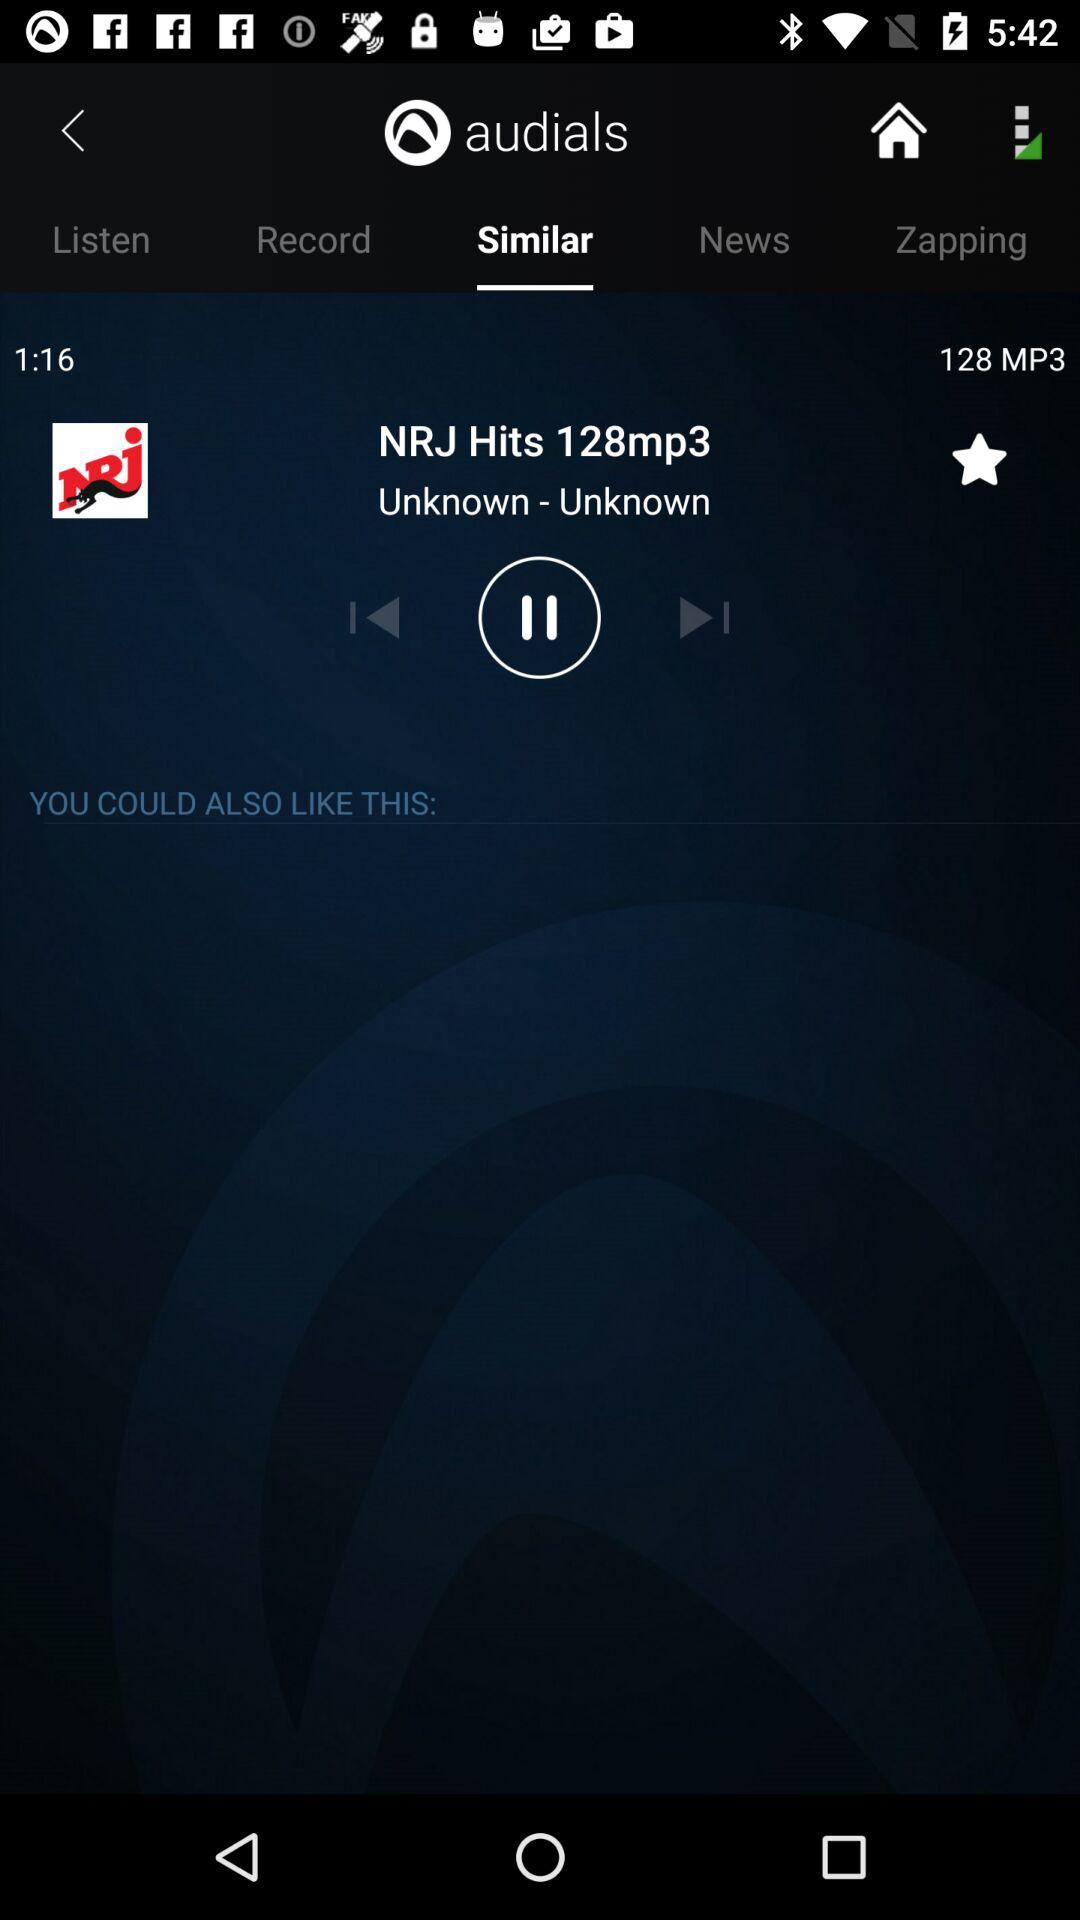Which tab is selected? The selected tab is "Similar". 